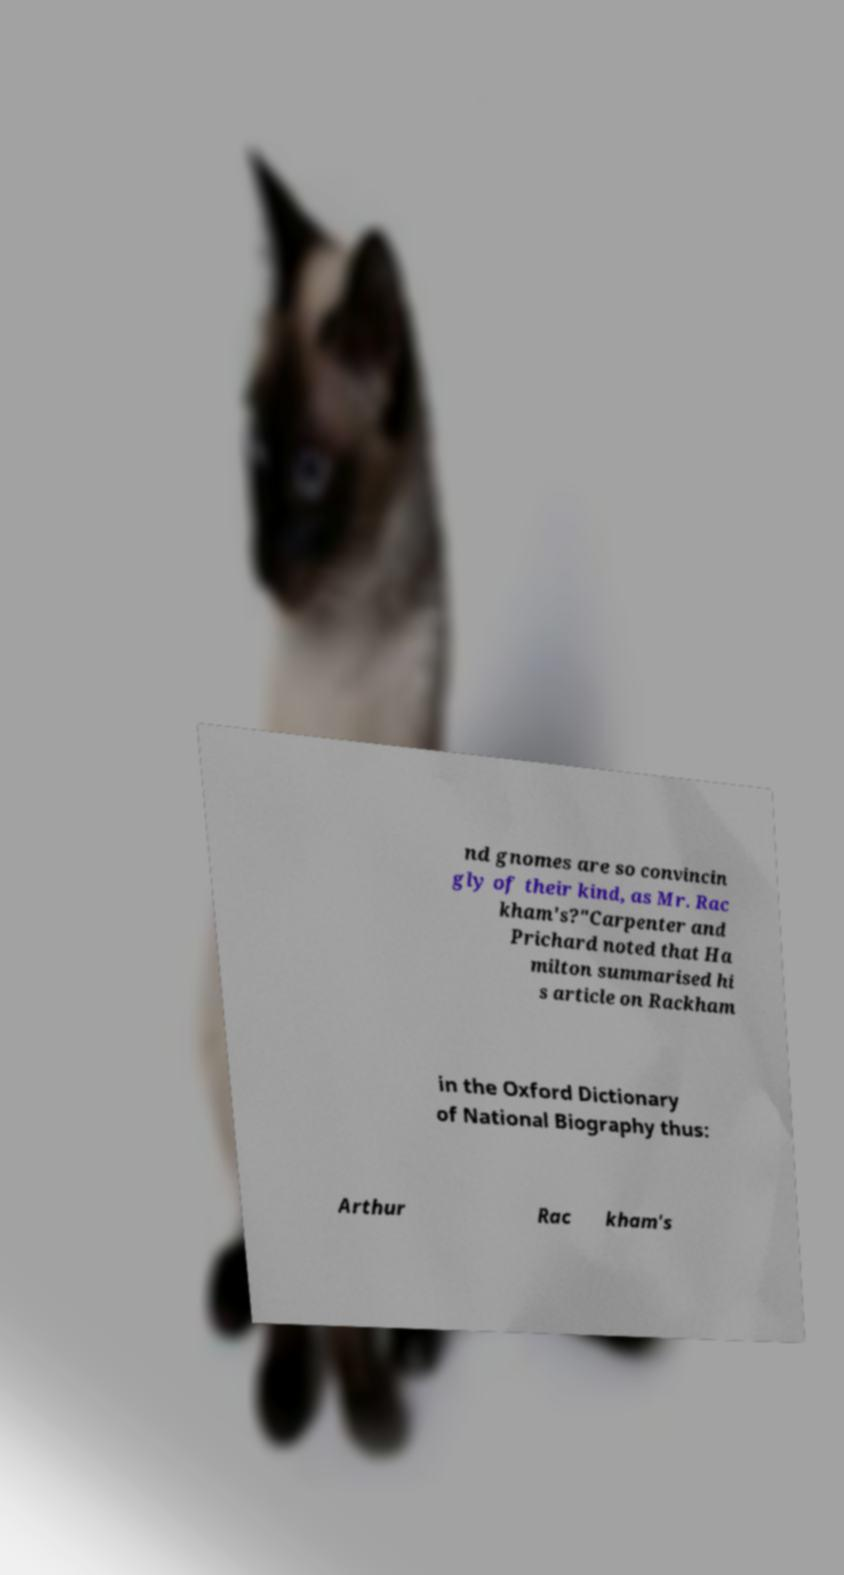What messages or text are displayed in this image? I need them in a readable, typed format. nd gnomes are so convincin gly of their kind, as Mr. Rac kham's?"Carpenter and Prichard noted that Ha milton summarised hi s article on Rackham in the Oxford Dictionary of National Biography thus: Arthur Rac kham's 